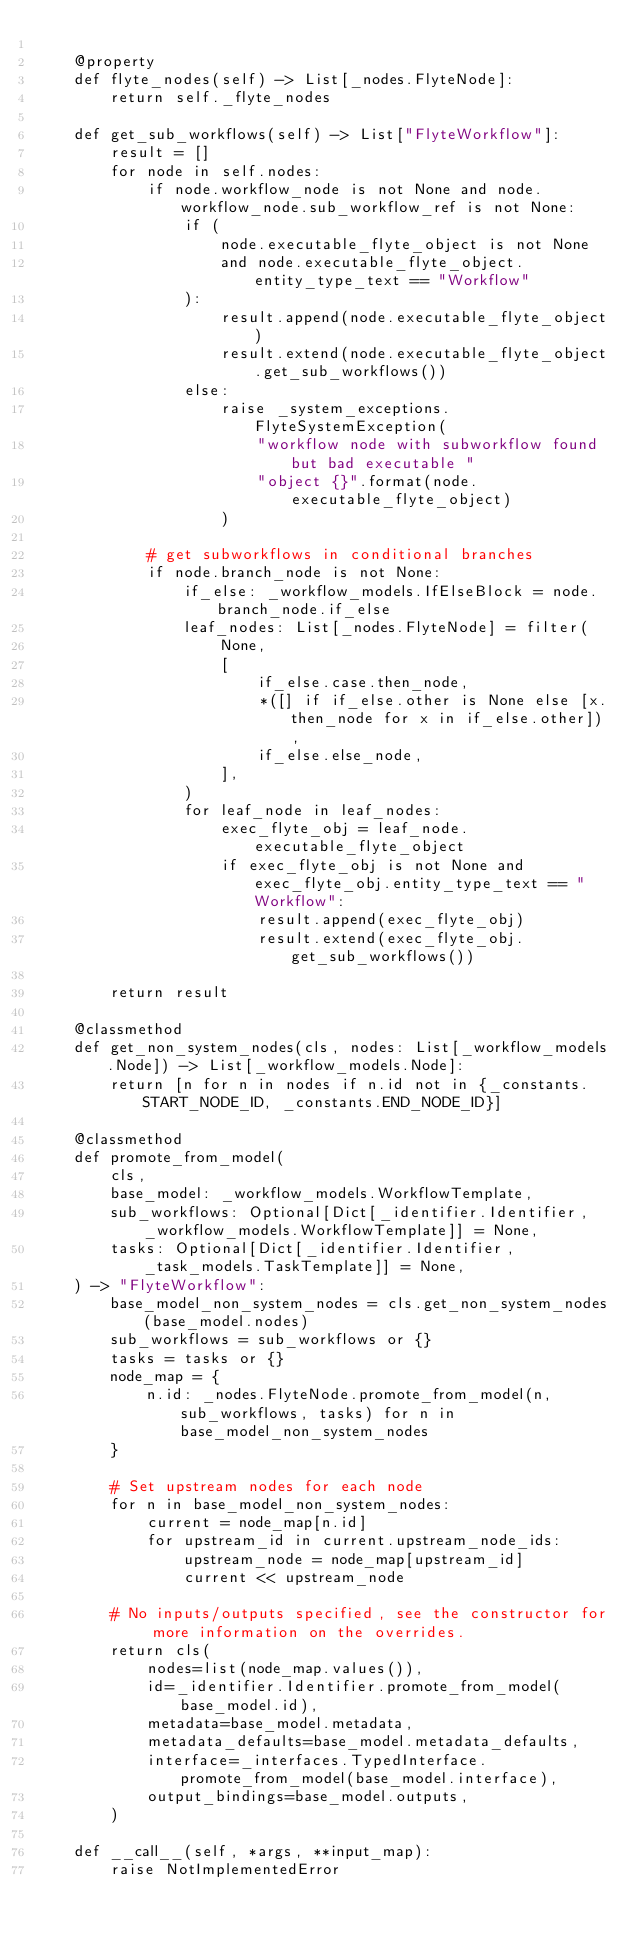<code> <loc_0><loc_0><loc_500><loc_500><_Python_>
    @property
    def flyte_nodes(self) -> List[_nodes.FlyteNode]:
        return self._flyte_nodes

    def get_sub_workflows(self) -> List["FlyteWorkflow"]:
        result = []
        for node in self.nodes:
            if node.workflow_node is not None and node.workflow_node.sub_workflow_ref is not None:
                if (
                    node.executable_flyte_object is not None
                    and node.executable_flyte_object.entity_type_text == "Workflow"
                ):
                    result.append(node.executable_flyte_object)
                    result.extend(node.executable_flyte_object.get_sub_workflows())
                else:
                    raise _system_exceptions.FlyteSystemException(
                        "workflow node with subworkflow found but bad executable "
                        "object {}".format(node.executable_flyte_object)
                    )

            # get subworkflows in conditional branches
            if node.branch_node is not None:
                if_else: _workflow_models.IfElseBlock = node.branch_node.if_else
                leaf_nodes: List[_nodes.FlyteNode] = filter(
                    None,
                    [
                        if_else.case.then_node,
                        *([] if if_else.other is None else [x.then_node for x in if_else.other]),
                        if_else.else_node,
                    ],
                )
                for leaf_node in leaf_nodes:
                    exec_flyte_obj = leaf_node.executable_flyte_object
                    if exec_flyte_obj is not None and exec_flyte_obj.entity_type_text == "Workflow":
                        result.append(exec_flyte_obj)
                        result.extend(exec_flyte_obj.get_sub_workflows())

        return result

    @classmethod
    def get_non_system_nodes(cls, nodes: List[_workflow_models.Node]) -> List[_workflow_models.Node]:
        return [n for n in nodes if n.id not in {_constants.START_NODE_ID, _constants.END_NODE_ID}]

    @classmethod
    def promote_from_model(
        cls,
        base_model: _workflow_models.WorkflowTemplate,
        sub_workflows: Optional[Dict[_identifier.Identifier, _workflow_models.WorkflowTemplate]] = None,
        tasks: Optional[Dict[_identifier.Identifier, _task_models.TaskTemplate]] = None,
    ) -> "FlyteWorkflow":
        base_model_non_system_nodes = cls.get_non_system_nodes(base_model.nodes)
        sub_workflows = sub_workflows or {}
        tasks = tasks or {}
        node_map = {
            n.id: _nodes.FlyteNode.promote_from_model(n, sub_workflows, tasks) for n in base_model_non_system_nodes
        }

        # Set upstream nodes for each node
        for n in base_model_non_system_nodes:
            current = node_map[n.id]
            for upstream_id in current.upstream_node_ids:
                upstream_node = node_map[upstream_id]
                current << upstream_node

        # No inputs/outputs specified, see the constructor for more information on the overrides.
        return cls(
            nodes=list(node_map.values()),
            id=_identifier.Identifier.promote_from_model(base_model.id),
            metadata=base_model.metadata,
            metadata_defaults=base_model.metadata_defaults,
            interface=_interfaces.TypedInterface.promote_from_model(base_model.interface),
            output_bindings=base_model.outputs,
        )

    def __call__(self, *args, **input_map):
        raise NotImplementedError
</code> 